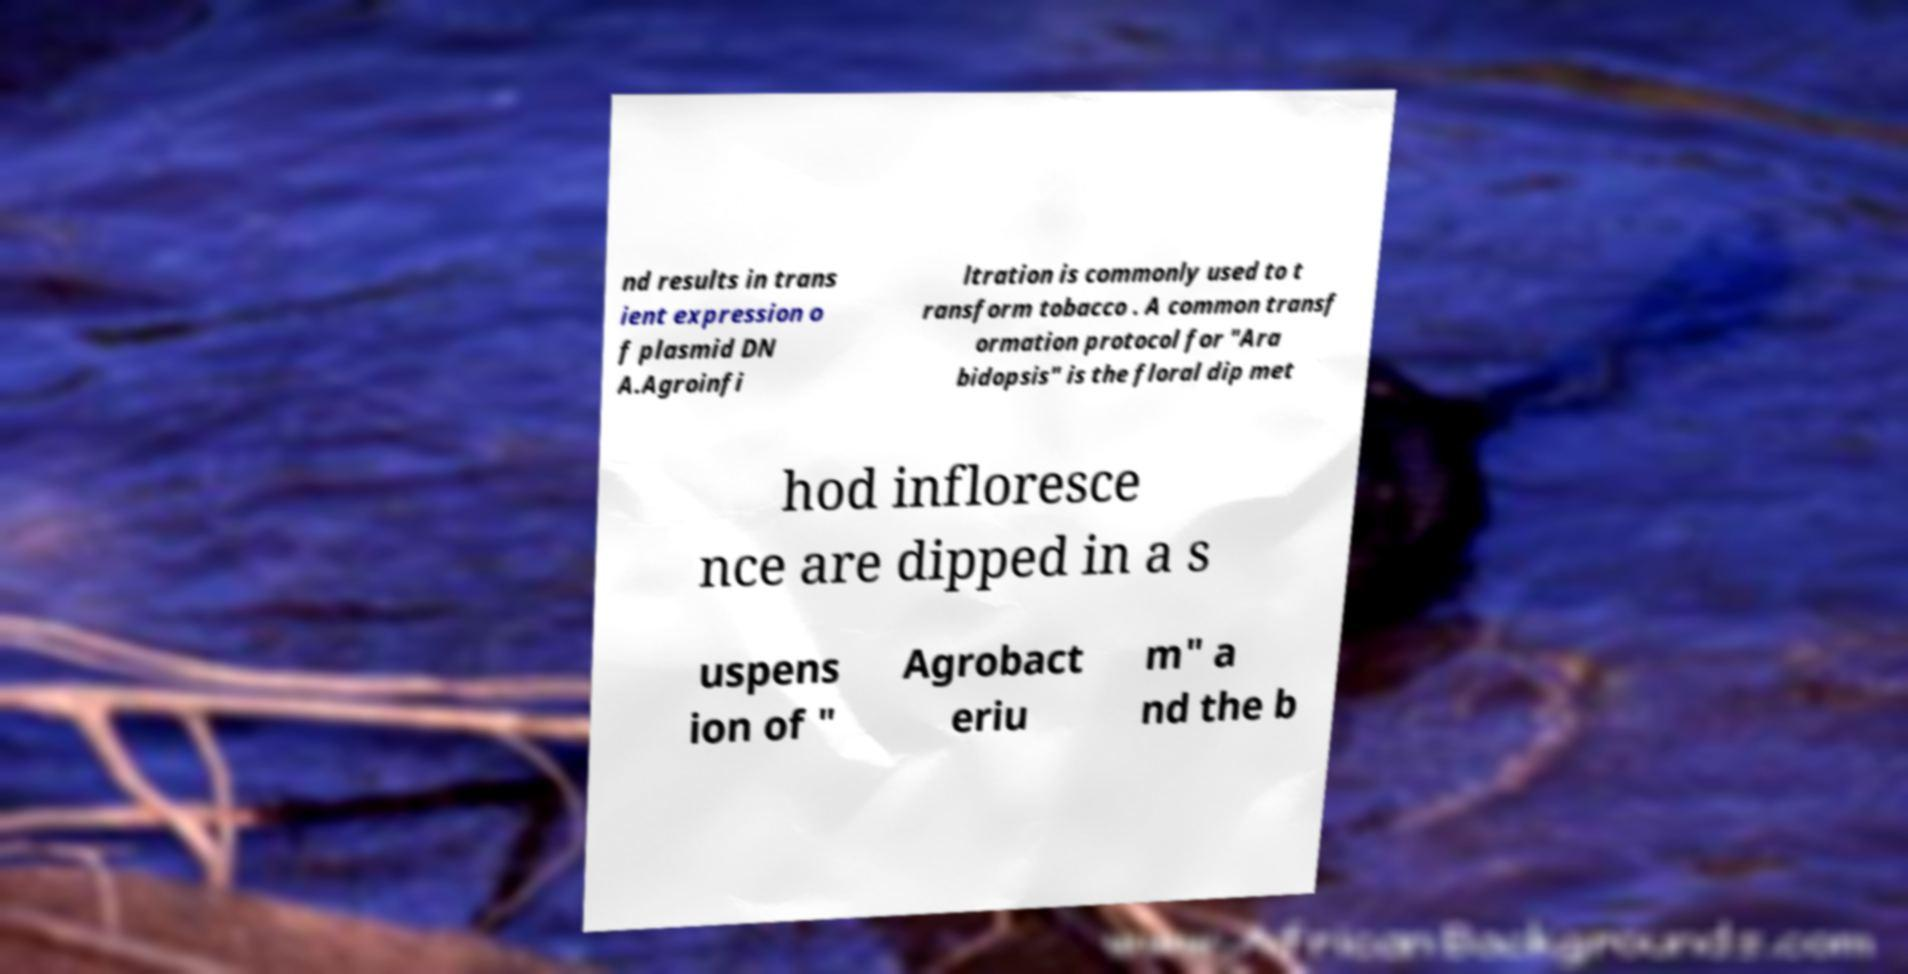Can you accurately transcribe the text from the provided image for me? nd results in trans ient expression o f plasmid DN A.Agroinfi ltration is commonly used to t ransform tobacco . A common transf ormation protocol for "Ara bidopsis" is the floral dip met hod infloresce nce are dipped in a s uspens ion of " Agrobact eriu m" a nd the b 